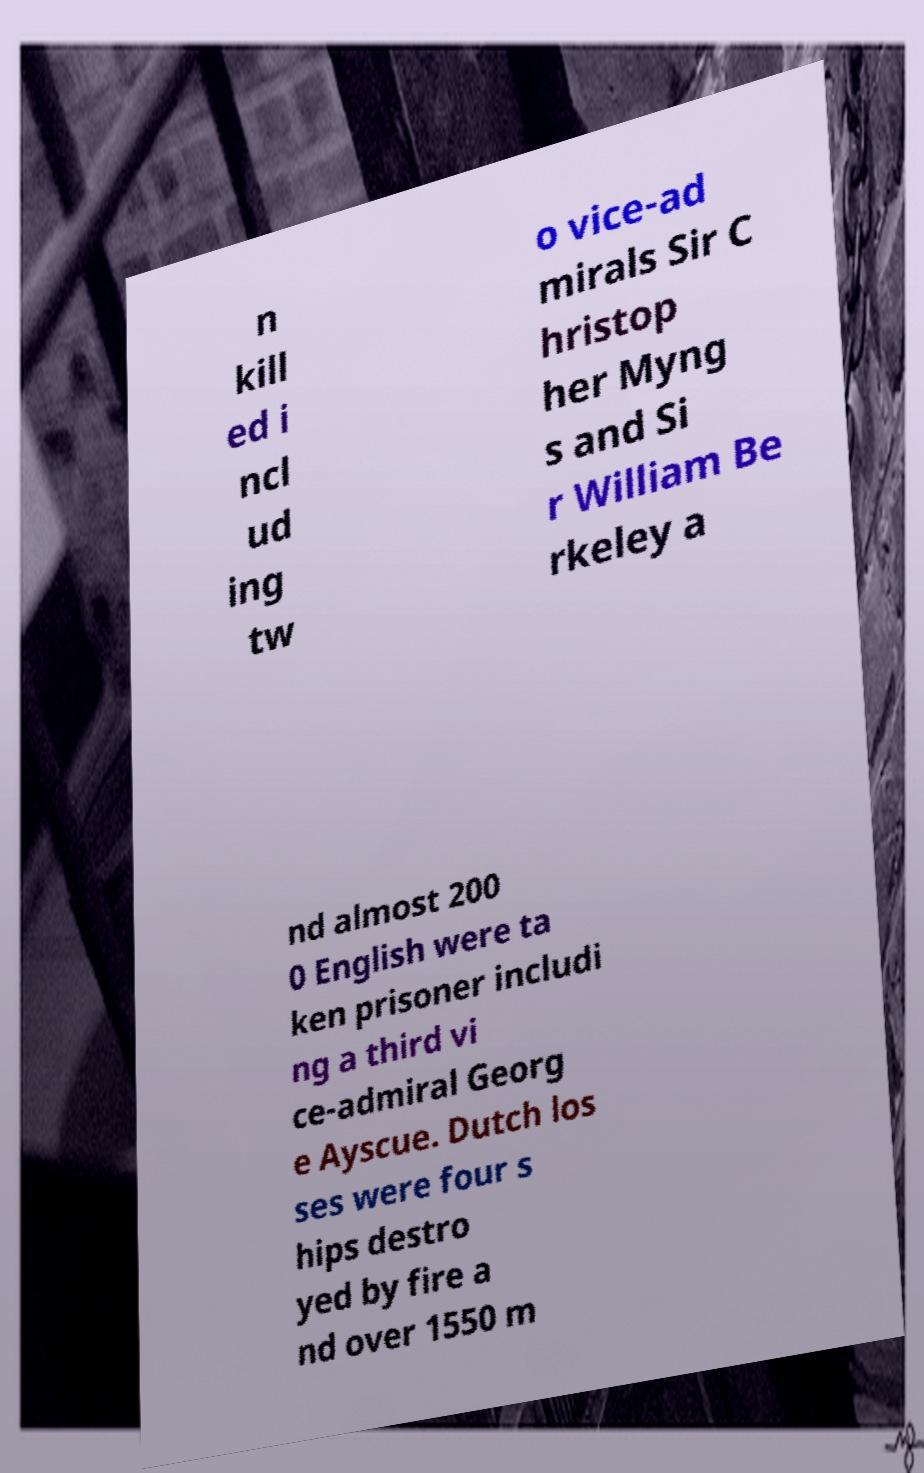What messages or text are displayed in this image? I need them in a readable, typed format. n kill ed i ncl ud ing tw o vice-ad mirals Sir C hristop her Myng s and Si r William Be rkeley a nd almost 200 0 English were ta ken prisoner includi ng a third vi ce-admiral Georg e Ayscue. Dutch los ses were four s hips destro yed by fire a nd over 1550 m 